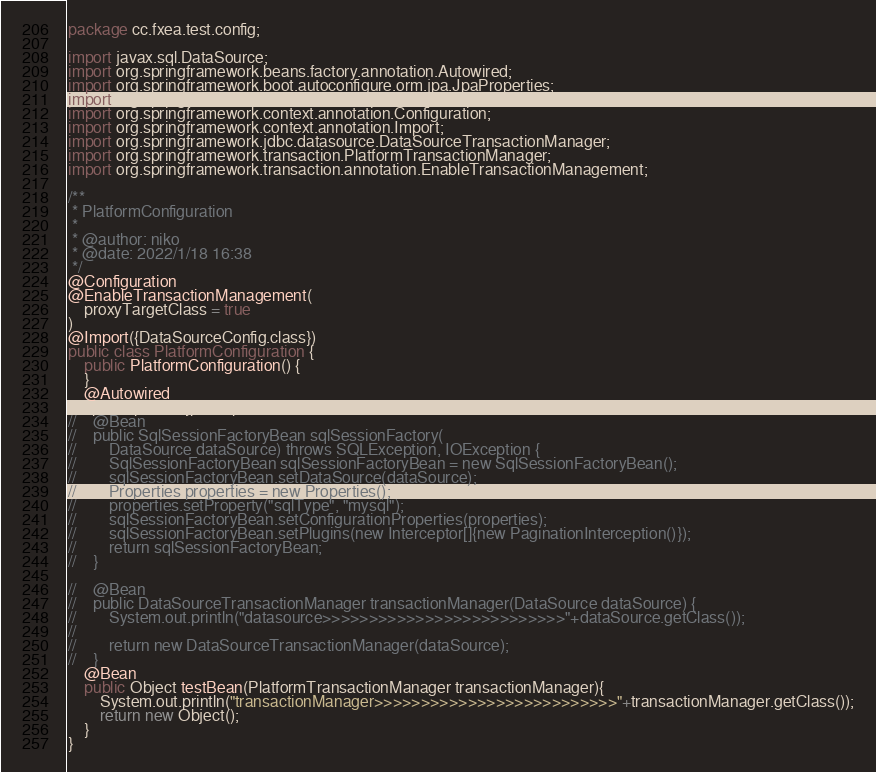Convert code to text. <code><loc_0><loc_0><loc_500><loc_500><_Java_>package cc.fxea.test.config;

import javax.sql.DataSource;
import org.springframework.beans.factory.annotation.Autowired;
import org.springframework.boot.autoconfigure.orm.jpa.JpaProperties;
import org.springframework.context.annotation.Bean;
import org.springframework.context.annotation.Configuration;
import org.springframework.context.annotation.Import;
import org.springframework.jdbc.datasource.DataSourceTransactionManager;
import org.springframework.transaction.PlatformTransactionManager;
import org.springframework.transaction.annotation.EnableTransactionManagement;

/**
 * PlatformConfiguration
 *
 * @author: niko
 * @date: 2022/1/18 16:38
 */
@Configuration
@EnableTransactionManagement(
    proxyTargetClass = true
)
@Import({DataSourceConfig.class})
public class PlatformConfiguration {
    public PlatformConfiguration() {
    }
    @Autowired
    JpaProperties jpaProperties;
//    @Bean
//    public SqlSessionFactoryBean sqlSessionFactory(
//        DataSource dataSource) throws SQLException, IOException {
//        SqlSessionFactoryBean sqlSessionFactoryBean = new SqlSessionFactoryBean();
//        sqlSessionFactoryBean.setDataSource(dataSource);
//        Properties properties = new Properties();
//        properties.setProperty("sqlType", "mysql");
//        sqlSessionFactoryBean.setConfigurationProperties(properties);
//        sqlSessionFactoryBean.setPlugins(new Interceptor[]{new PaginationInterception()});
//        return sqlSessionFactoryBean;
//    }

//    @Bean
//    public DataSourceTransactionManager transactionManager(DataSource dataSource) {
//        System.out.println("datasource>>>>>>>>>>>>>>>>>>>>>>>>>>"+dataSource.getClass());
//
//        return new DataSourceTransactionManager(dataSource);
//    }
    @Bean
    public Object testBean(PlatformTransactionManager transactionManager){
        System.out.println("transactionManager>>>>>>>>>>>>>>>>>>>>>>>>>>"+transactionManager.getClass());
        return new Object();
    }
}

</code> 